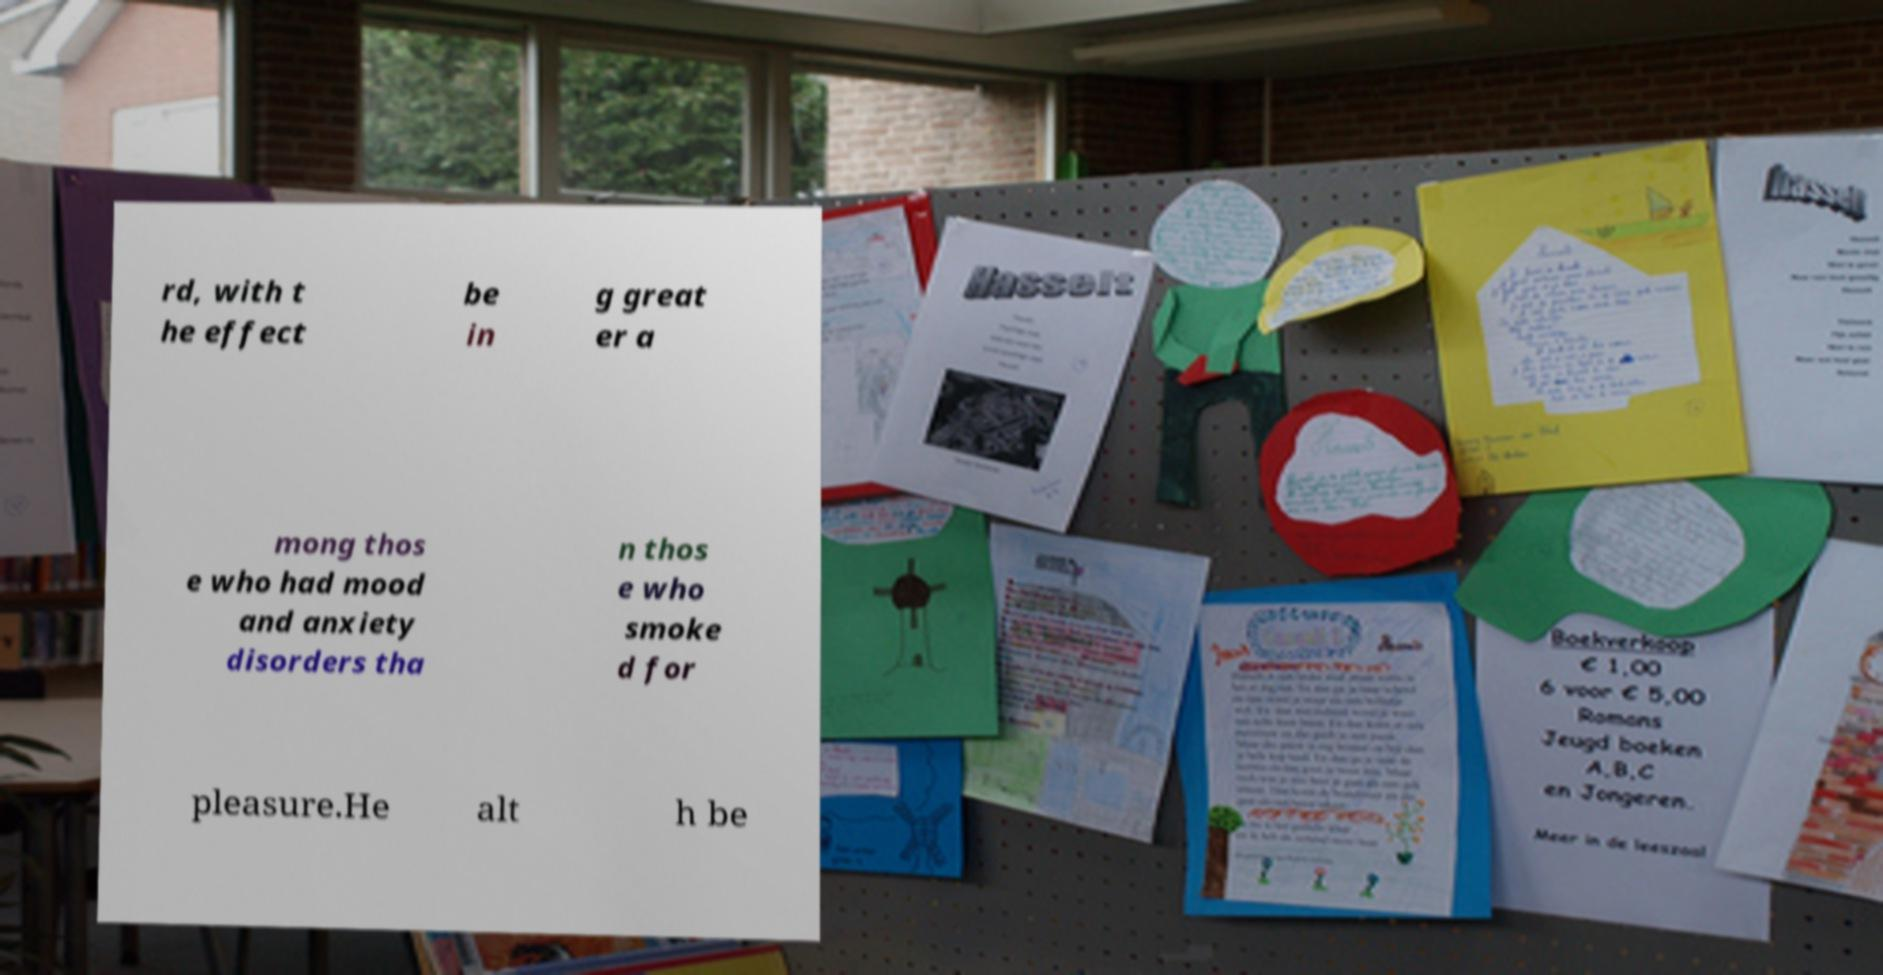Could you assist in decoding the text presented in this image and type it out clearly? rd, with t he effect be in g great er a mong thos e who had mood and anxiety disorders tha n thos e who smoke d for pleasure.He alt h be 